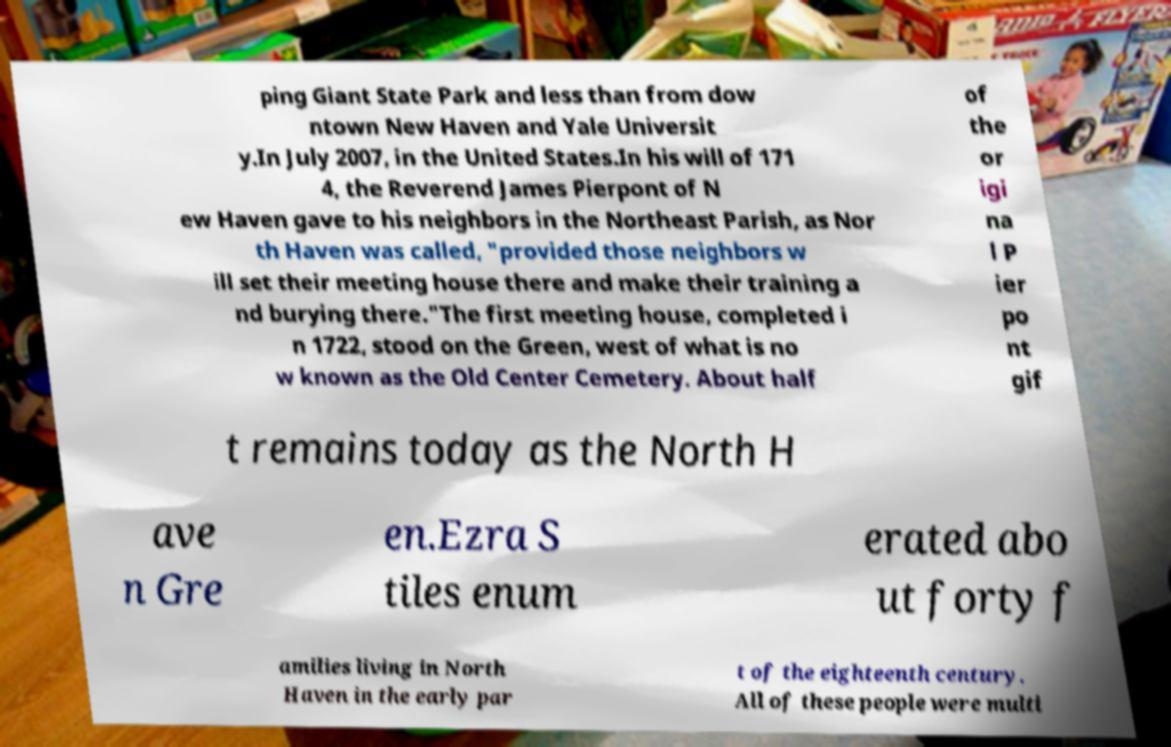There's text embedded in this image that I need extracted. Can you transcribe it verbatim? ping Giant State Park and less than from dow ntown New Haven and Yale Universit y.In July 2007, in the United States.In his will of 171 4, the Reverend James Pierpont of N ew Haven gave to his neighbors in the Northeast Parish, as Nor th Haven was called, "provided those neighbors w ill set their meeting house there and make their training a nd burying there."The first meeting house, completed i n 1722, stood on the Green, west of what is no w known as the Old Center Cemetery. About half of the or igi na l P ier po nt gif t remains today as the North H ave n Gre en.Ezra S tiles enum erated abo ut forty f amilies living in North Haven in the early par t of the eighteenth century. All of these people were multi 